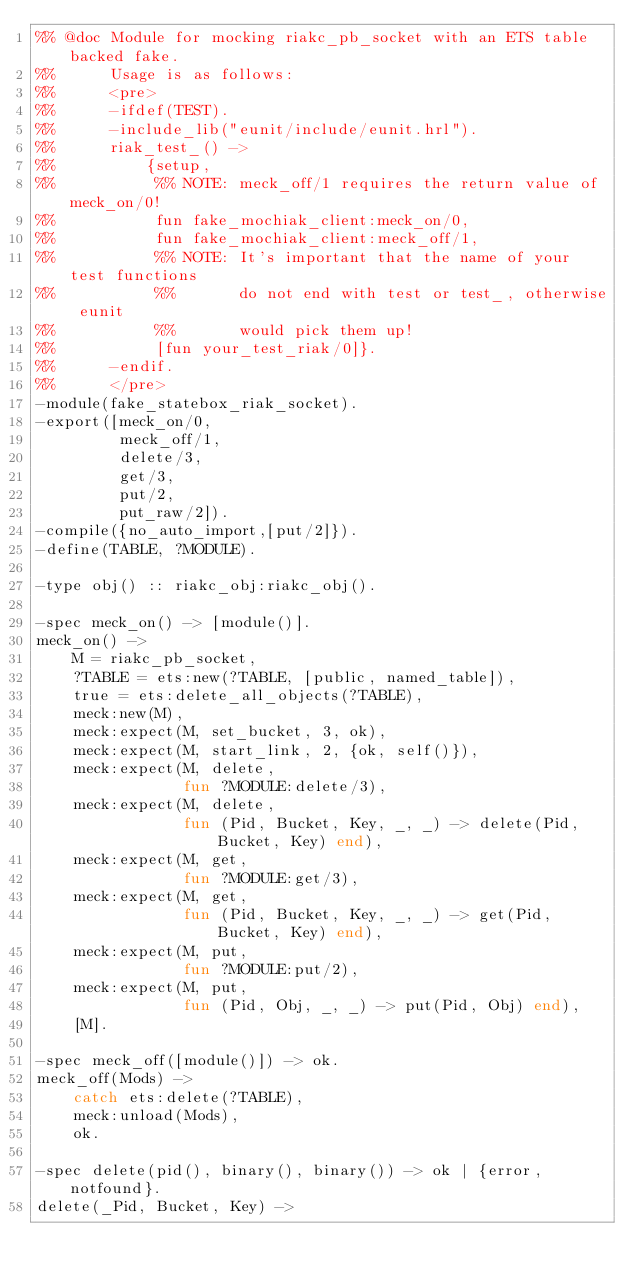Convert code to text. <code><loc_0><loc_0><loc_500><loc_500><_Erlang_>%% @doc Module for mocking riakc_pb_socket with an ETS table backed fake.
%%      Usage is as follows:
%%      <pre>
%%      -ifdef(TEST).
%%      -include_lib("eunit/include/eunit.hrl").
%%      riak_test_() ->
%%          {setup,
%%           %% NOTE: meck_off/1 requires the return value of meck_on/0!
%%           fun fake_mochiak_client:meck_on/0,
%%           fun fake_mochiak_client:meck_off/1,
%%           %% NOTE: It's important that the name of your test functions
%%           %%       do not end with test or test_, otherwise eunit
%%           %%       would pick them up!
%%           [fun your_test_riak/0]}.
%%      -endif.
%%      </pre>
-module(fake_statebox_riak_socket).
-export([meck_on/0,
         meck_off/1,
         delete/3,
         get/3,
         put/2,
         put_raw/2]).
-compile({no_auto_import,[put/2]}).
-define(TABLE, ?MODULE).

-type obj() :: riakc_obj:riakc_obj().

-spec meck_on() -> [module()].
meck_on() ->
    M = riakc_pb_socket,
    ?TABLE = ets:new(?TABLE, [public, named_table]),
    true = ets:delete_all_objects(?TABLE),
    meck:new(M),
    meck:expect(M, set_bucket, 3, ok),
    meck:expect(M, start_link, 2, {ok, self()}),
    meck:expect(M, delete,
                fun ?MODULE:delete/3),
    meck:expect(M, delete,
                fun (Pid, Bucket, Key, _, _) -> delete(Pid, Bucket, Key) end),
    meck:expect(M, get,
                fun ?MODULE:get/3),
    meck:expect(M, get,
                fun (Pid, Bucket, Key, _, _) -> get(Pid, Bucket, Key) end),
    meck:expect(M, put,
                fun ?MODULE:put/2),
    meck:expect(M, put,
                fun (Pid, Obj, _, _) -> put(Pid, Obj) end),
    [M].

-spec meck_off([module()]) -> ok.
meck_off(Mods) ->
    catch ets:delete(?TABLE),
    meck:unload(Mods),
    ok.

-spec delete(pid(), binary(), binary()) -> ok | {error, notfound}.
delete(_Pid, Bucket, Key) -></code> 